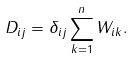Convert formula to latex. <formula><loc_0><loc_0><loc_500><loc_500>D _ { i j } = \delta _ { i j } \sum _ { k = 1 } ^ { n } W _ { i k } .</formula> 